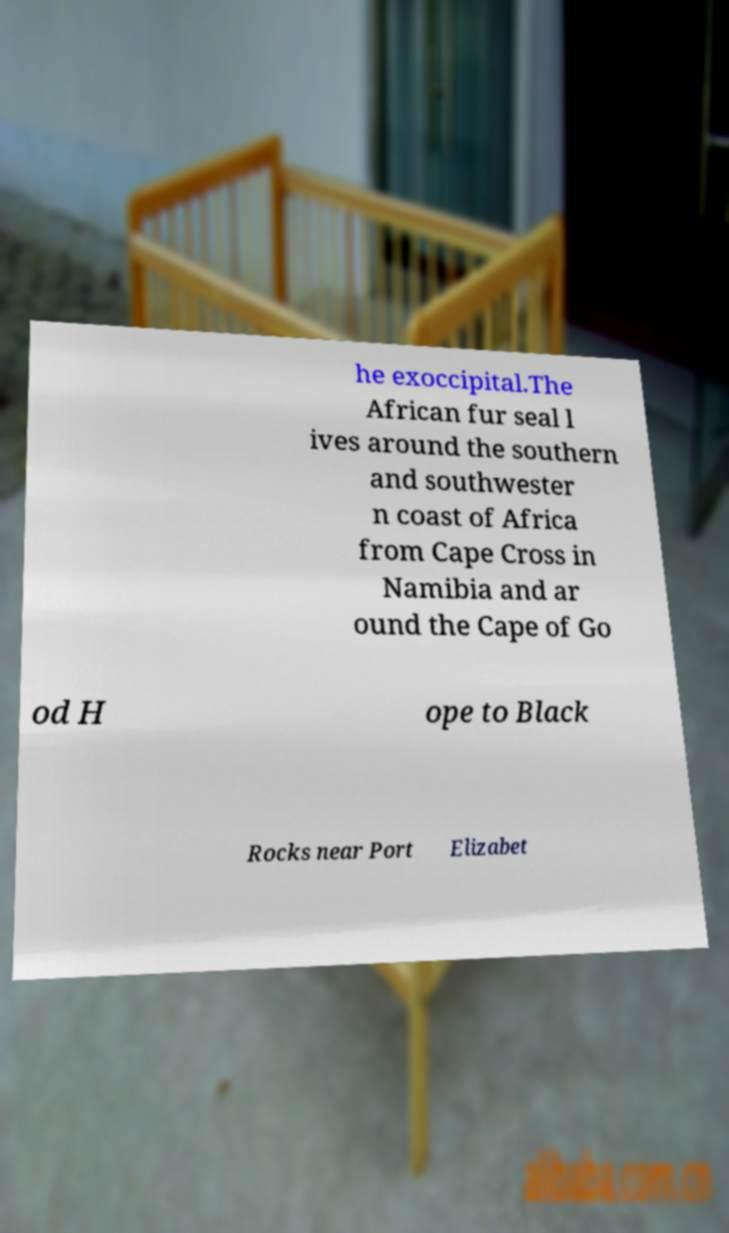Please read and relay the text visible in this image. What does it say? he exoccipital.The African fur seal l ives around the southern and southwester n coast of Africa from Cape Cross in Namibia and ar ound the Cape of Go od H ope to Black Rocks near Port Elizabet 